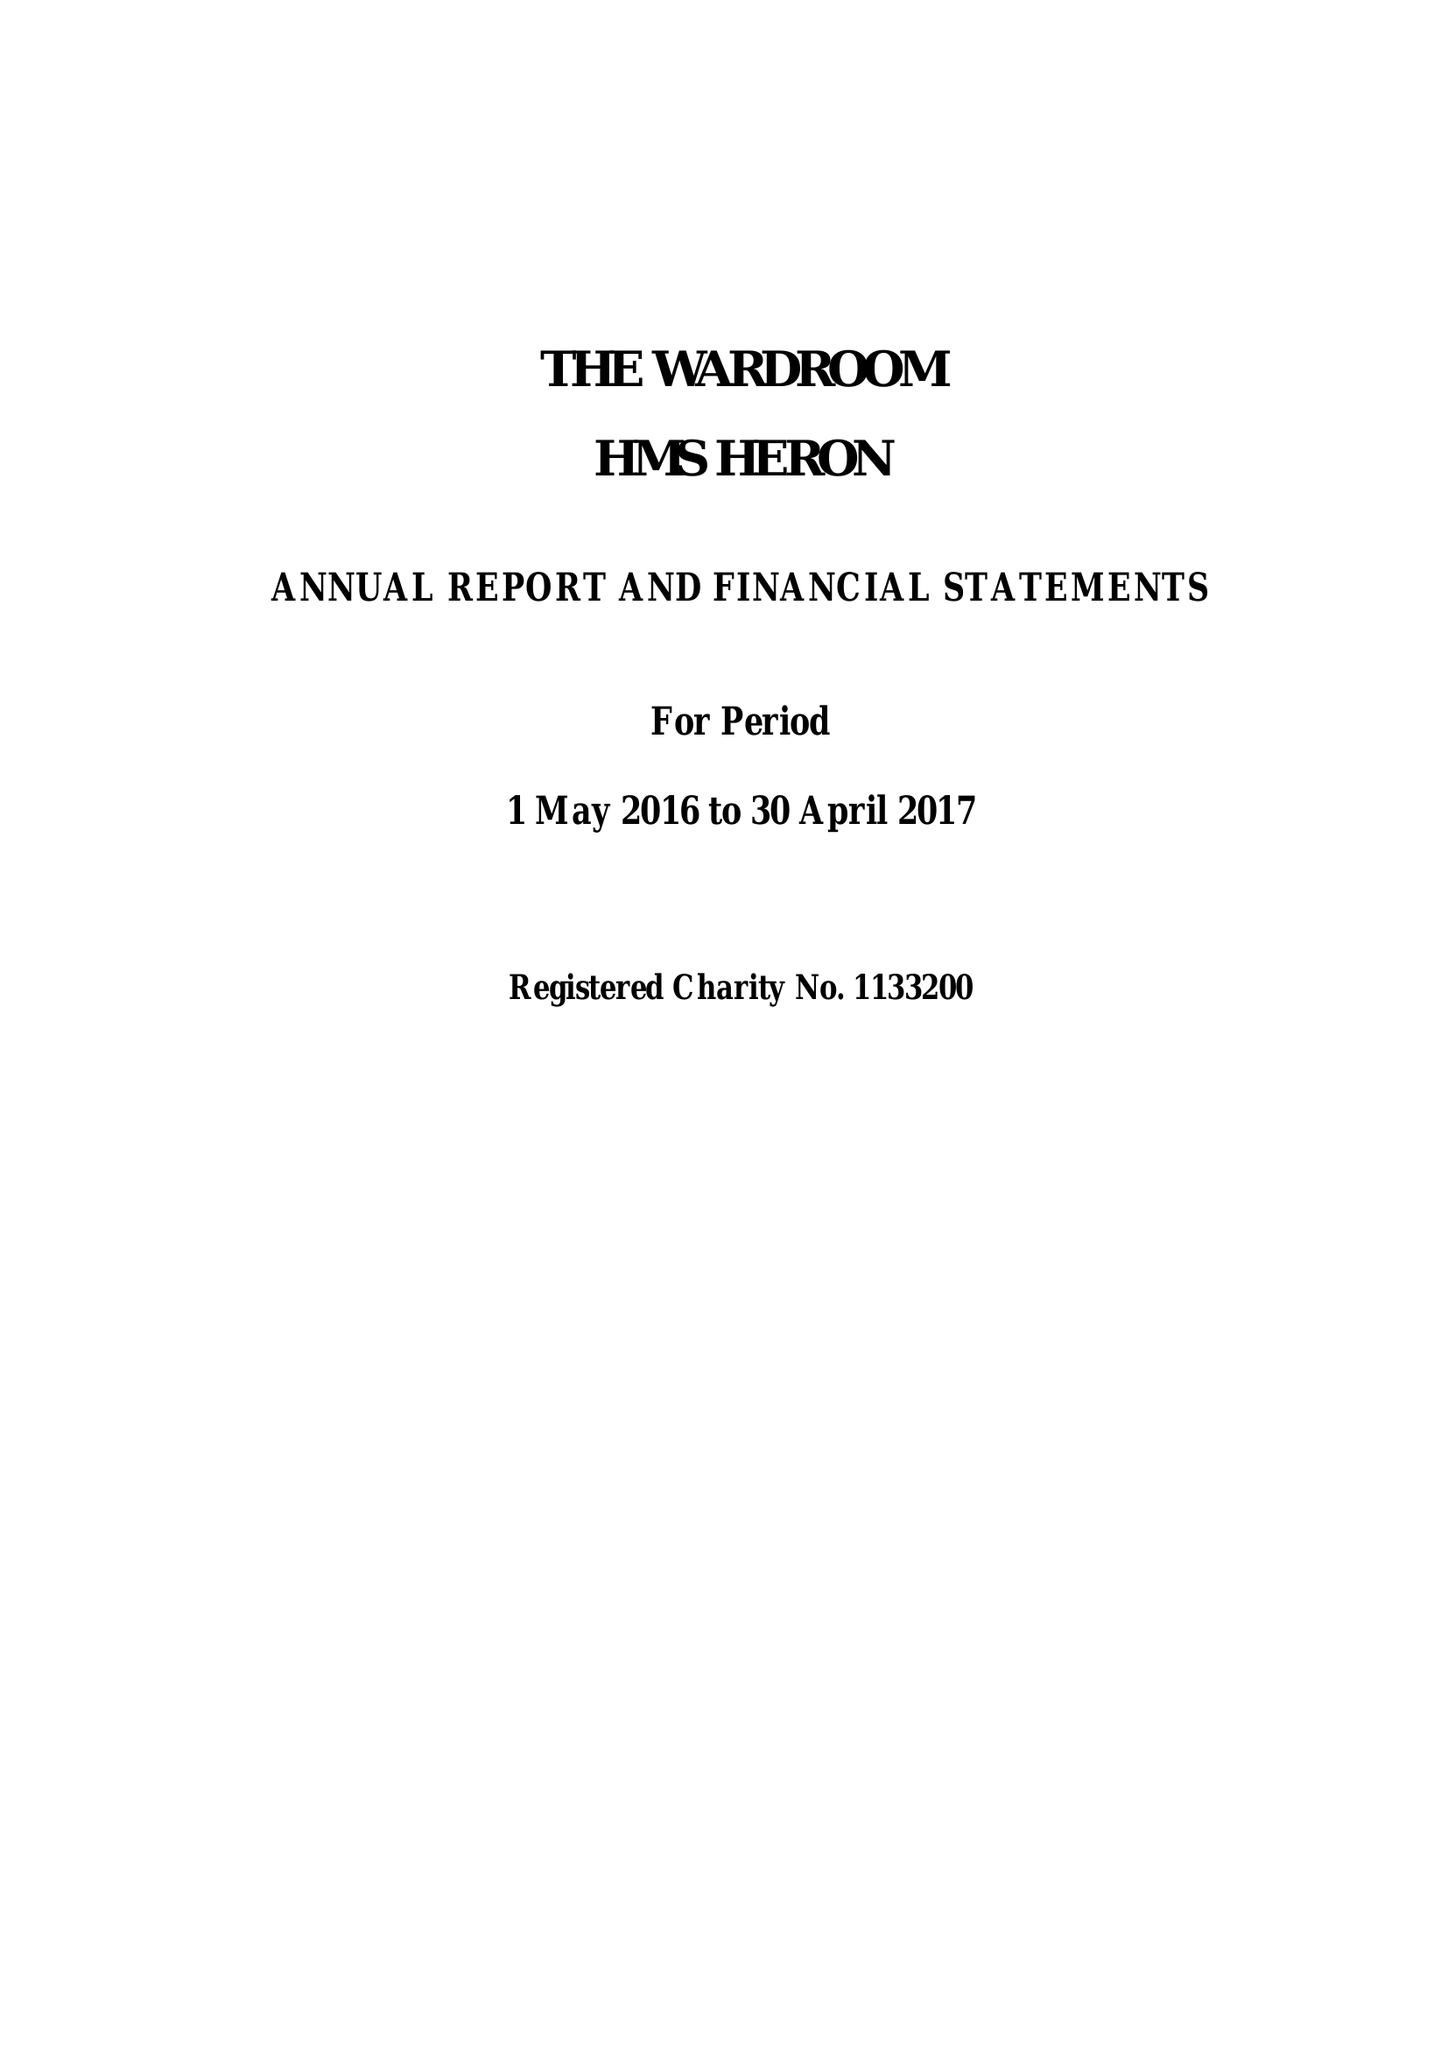What is the value for the spending_annually_in_british_pounds?
Answer the question using a single word or phrase. 290429.90 